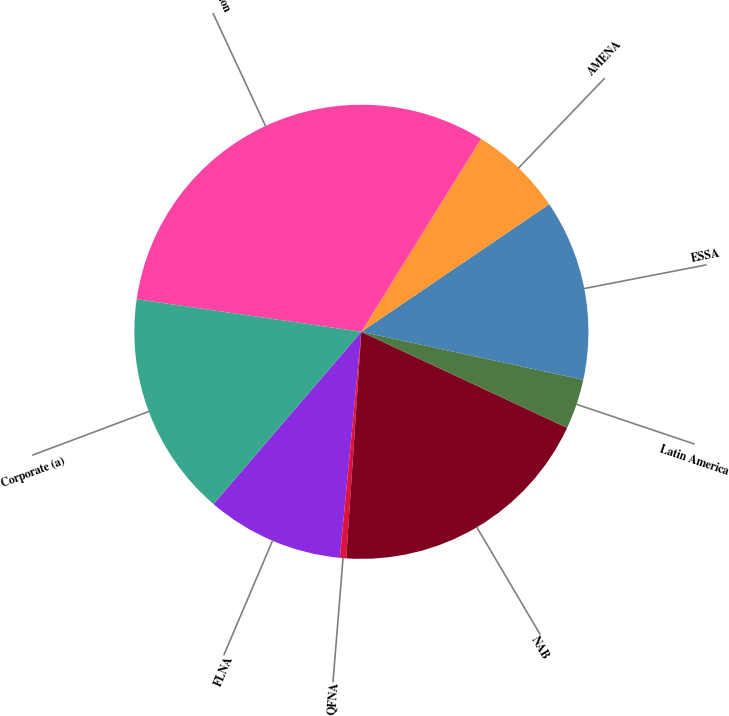<chart> <loc_0><loc_0><loc_500><loc_500><pie_chart><fcel>FLNA<fcel>QFNA<fcel>NAB<fcel>Latin America<fcel>ESSA<fcel>AMENA<fcel>Total division<fcel>Corporate (a)<nl><fcel>9.78%<fcel>0.45%<fcel>19.11%<fcel>3.56%<fcel>12.89%<fcel>6.67%<fcel>31.55%<fcel>16.0%<nl></chart> 